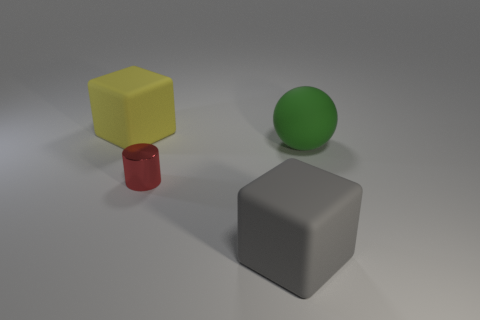Add 2 gray blocks. How many objects exist? 6 Subtract all cylinders. How many objects are left? 3 Subtract all big objects. Subtract all gray blocks. How many objects are left? 0 Add 1 big spheres. How many big spheres are left? 2 Add 3 large metallic spheres. How many large metallic spheres exist? 3 Subtract 0 red blocks. How many objects are left? 4 